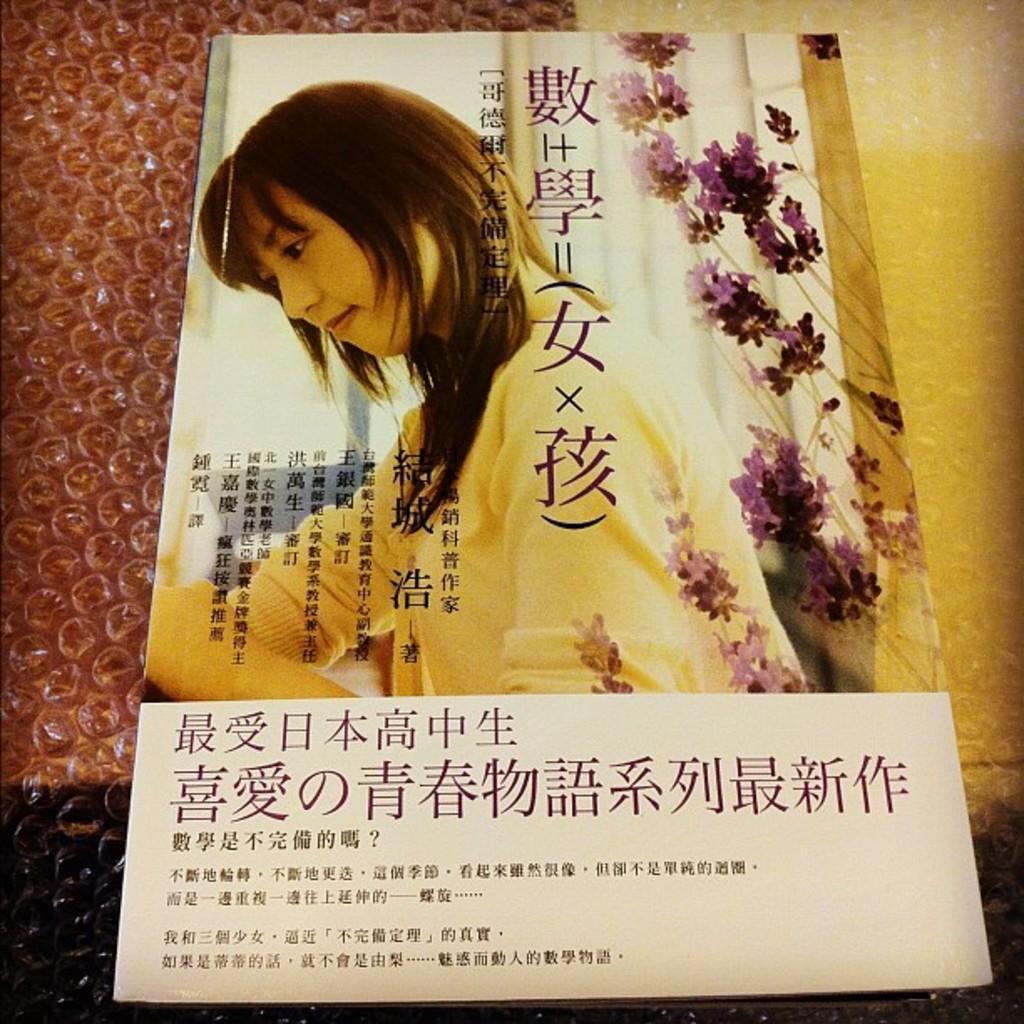Can you describe this image briefly? In this picture we can see a poster on a air bubble cover, on this poster we can see a woman, flowers and text. 